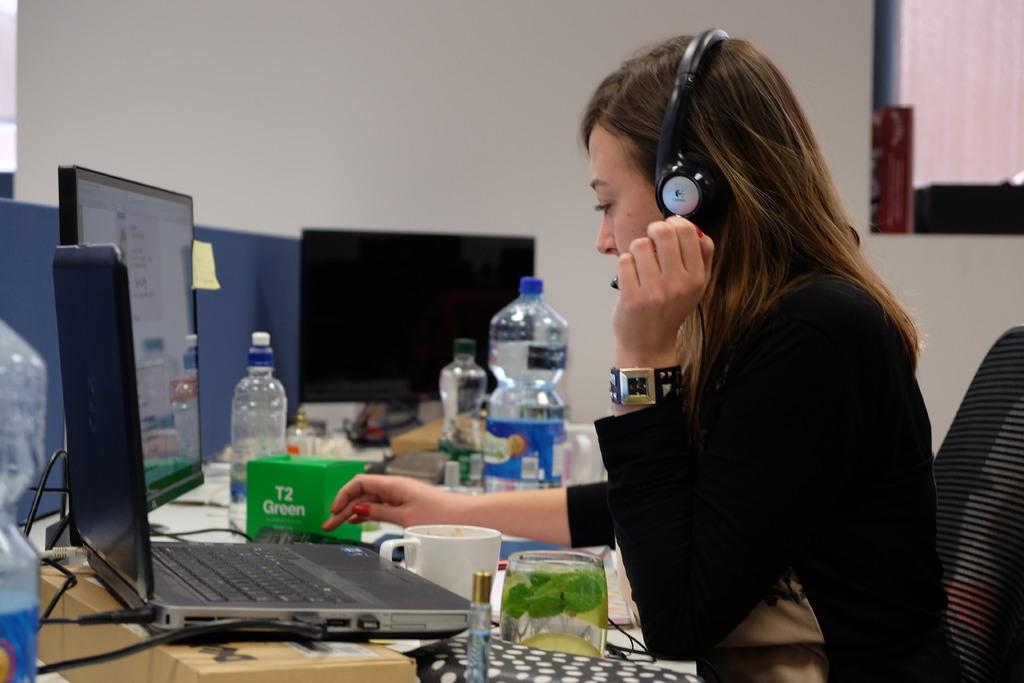<image>
Present a compact description of the photo's key features. A woman using her laptop next to a green box that says "T2 Green". 